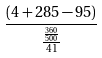<formula> <loc_0><loc_0><loc_500><loc_500>\frac { ( 4 + 2 8 5 - 9 5 ) } { \frac { \frac { 3 6 0 } { 5 0 0 } } { 4 1 } }</formula> 